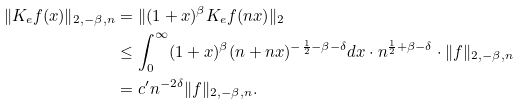Convert formula to latex. <formula><loc_0><loc_0><loc_500><loc_500>\| K _ { e } f ( x ) \| _ { 2 , - \beta , n } & = \| ( 1 + x ) ^ { \beta } K _ { e } f ( n x ) \| _ { 2 } \\ & \leq \int _ { 0 } ^ { \infty } ( 1 + x ) ^ { \beta } ( n + n x ) ^ { - \frac { 1 } { 2 } - \beta - \delta } d x \cdot n ^ { \frac { 1 } { 2 } + \beta - \delta } \cdot \| f \| _ { 2 , - \beta , n } \\ & = c ^ { \prime } n ^ { - 2 \delta } \| f \| _ { 2 , - \beta , n } .</formula> 